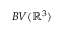Convert formula to latex. <formula><loc_0><loc_0><loc_500><loc_500>B V ( \mathbb { R } ^ { 3 } )</formula> 